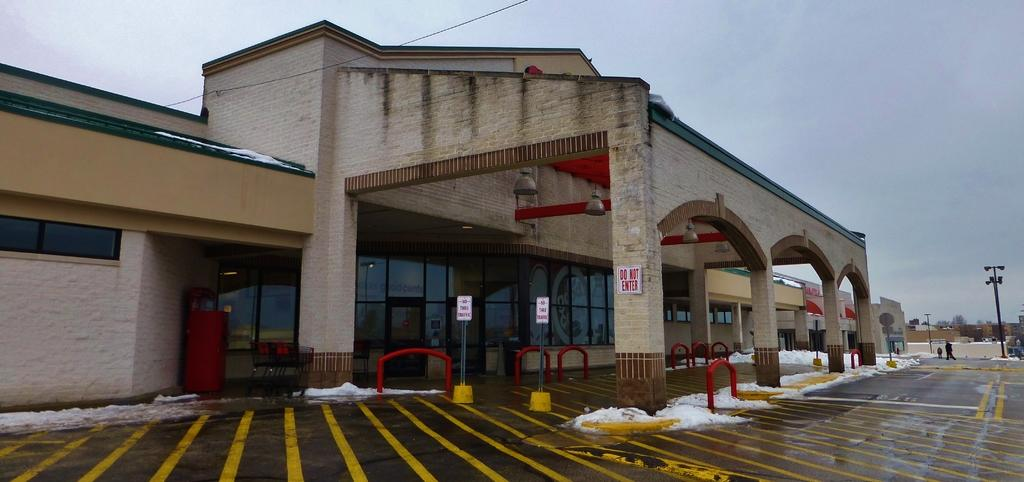<image>
Offer a succinct explanation of the picture presented. the words do not enter are on a white sign 